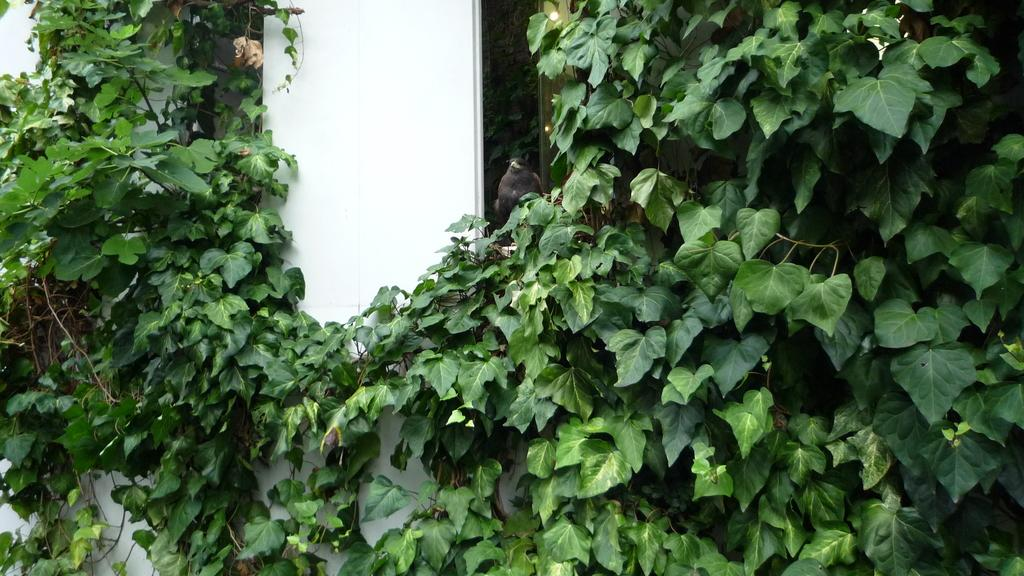What type of living organisms can be seen in the image? Plants can be seen in the image. What color are the plants in the image? The plants are green. What type of animal is present in the image? There is a brown color bird in the image. What color is the wall in the background of the image? The wall in the background of the image is white. How many cherries are hanging from the branches of the plants in the image? There are no cherries present in the image; the plants are green and do not have any cherries. What angle is the bird flying at in the image? The image does not show the bird in motion, so it is not possible to determine the angle at which it might be flying. 